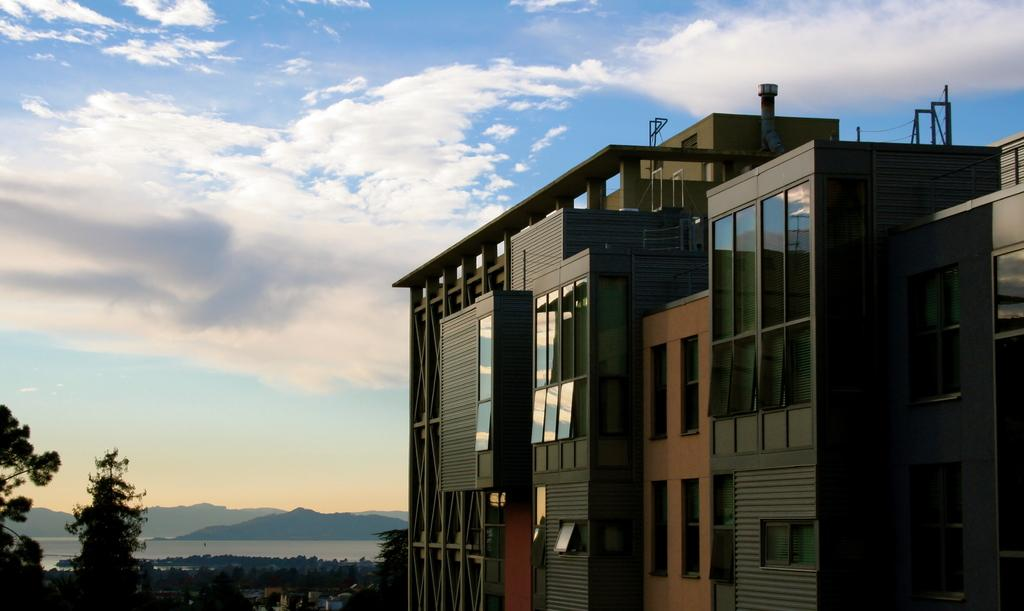What type of structures can be seen in the image? There are buildings in the image. What other natural elements are present in the image? There are trees in the image. What can be seen in the distance in the background of the image? Hills and water are visible in the background of the image. What part of the natural environment is visible in the background of the image? The sky is visible in the background of the image. Where is the aunt standing with her sheep in the image? There is no aunt or sheep present in the image. 